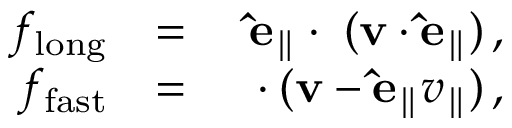Convert formula to latex. <formula><loc_0><loc_0><loc_500><loc_500>\begin{array} { r l r } { f _ { l o n g } } & { = } & { \hat { e } _ { \| } \cdot \nabla ( v \cdot \hat { e } _ { \| } ) \, , } \\ { f _ { f a s t } } & { = } & { \nabla \cdot ( v - \hat { e } _ { \| } v _ { \| } ) \, , } \end{array}</formula> 